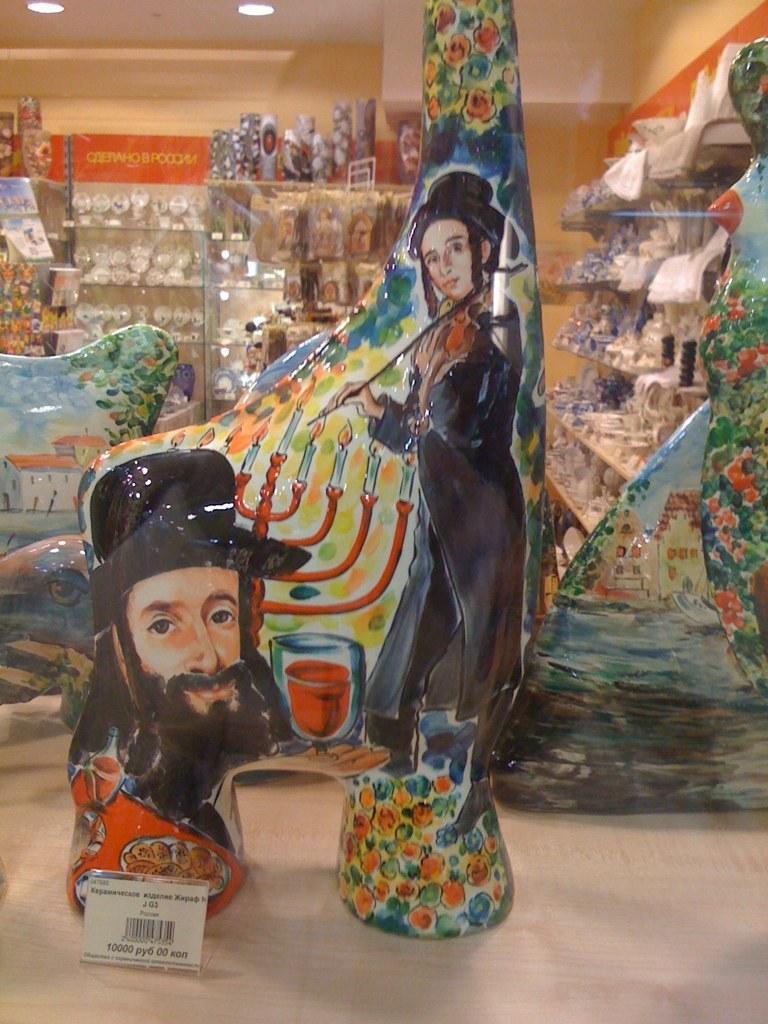Can you describe this image briefly? In this image we can see printed glass show pieces on the surface. There is a tag at the bottom of the image. In the background of the image we can see so many objects are arranged in different racks. At the top of the image, we can see roof with lights. 